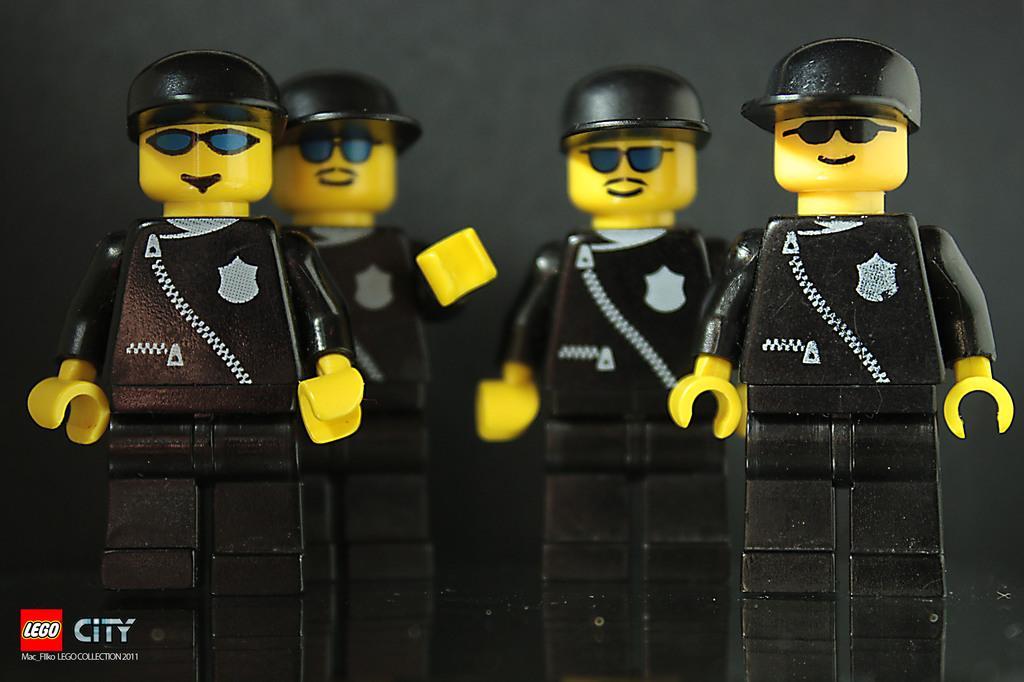Can you describe this image briefly? In this picture I can see some toys. 